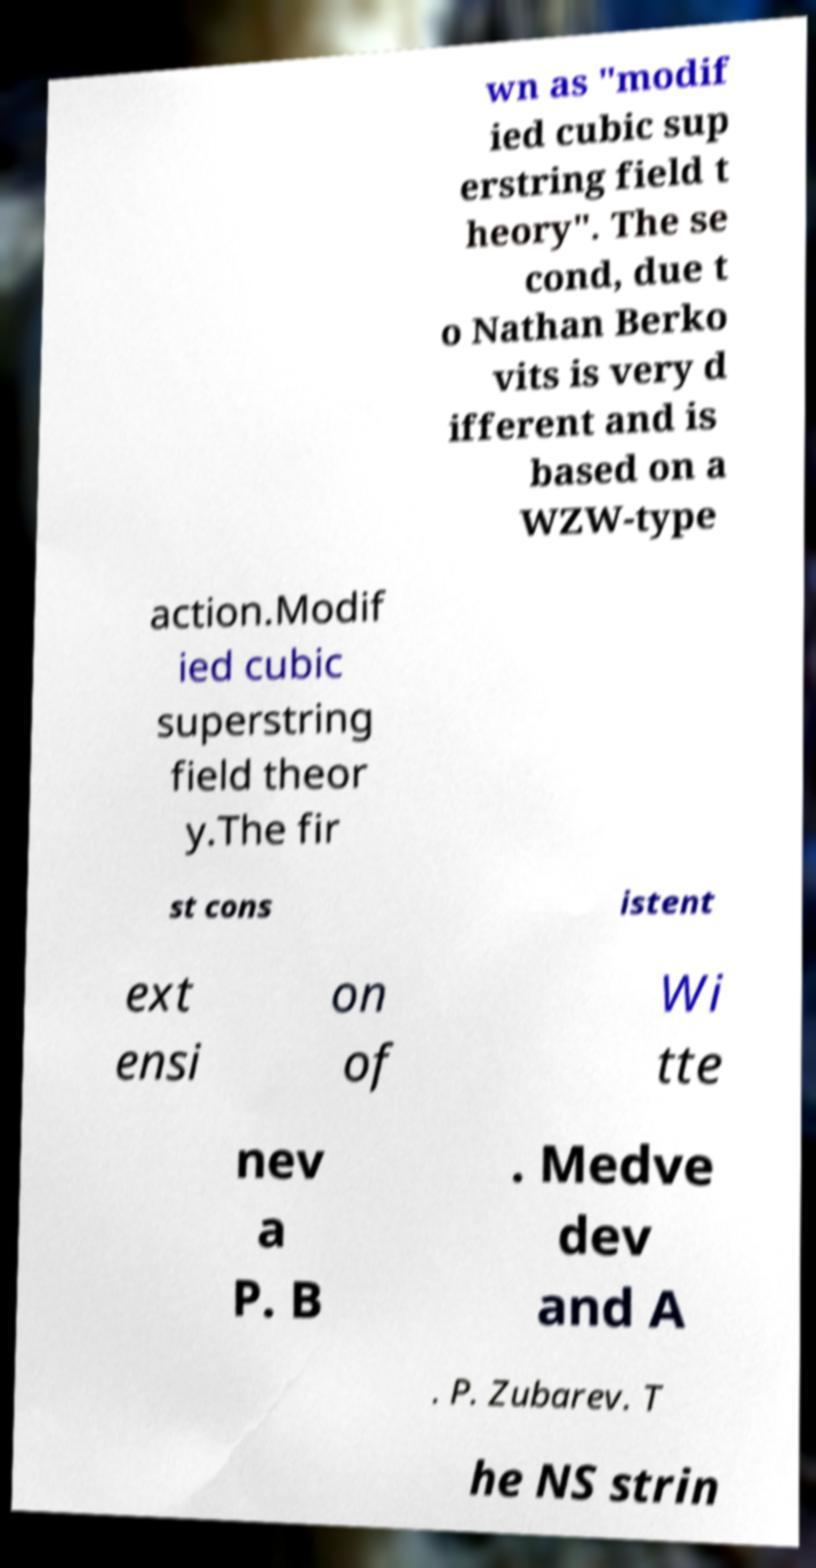What messages or text are displayed in this image? I need them in a readable, typed format. wn as "modif ied cubic sup erstring field t heory". The se cond, due t o Nathan Berko vits is very d ifferent and is based on a WZW-type action.Modif ied cubic superstring field theor y.The fir st cons istent ext ensi on of Wi tte nev a P. B . Medve dev and A . P. Zubarev. T he NS strin 